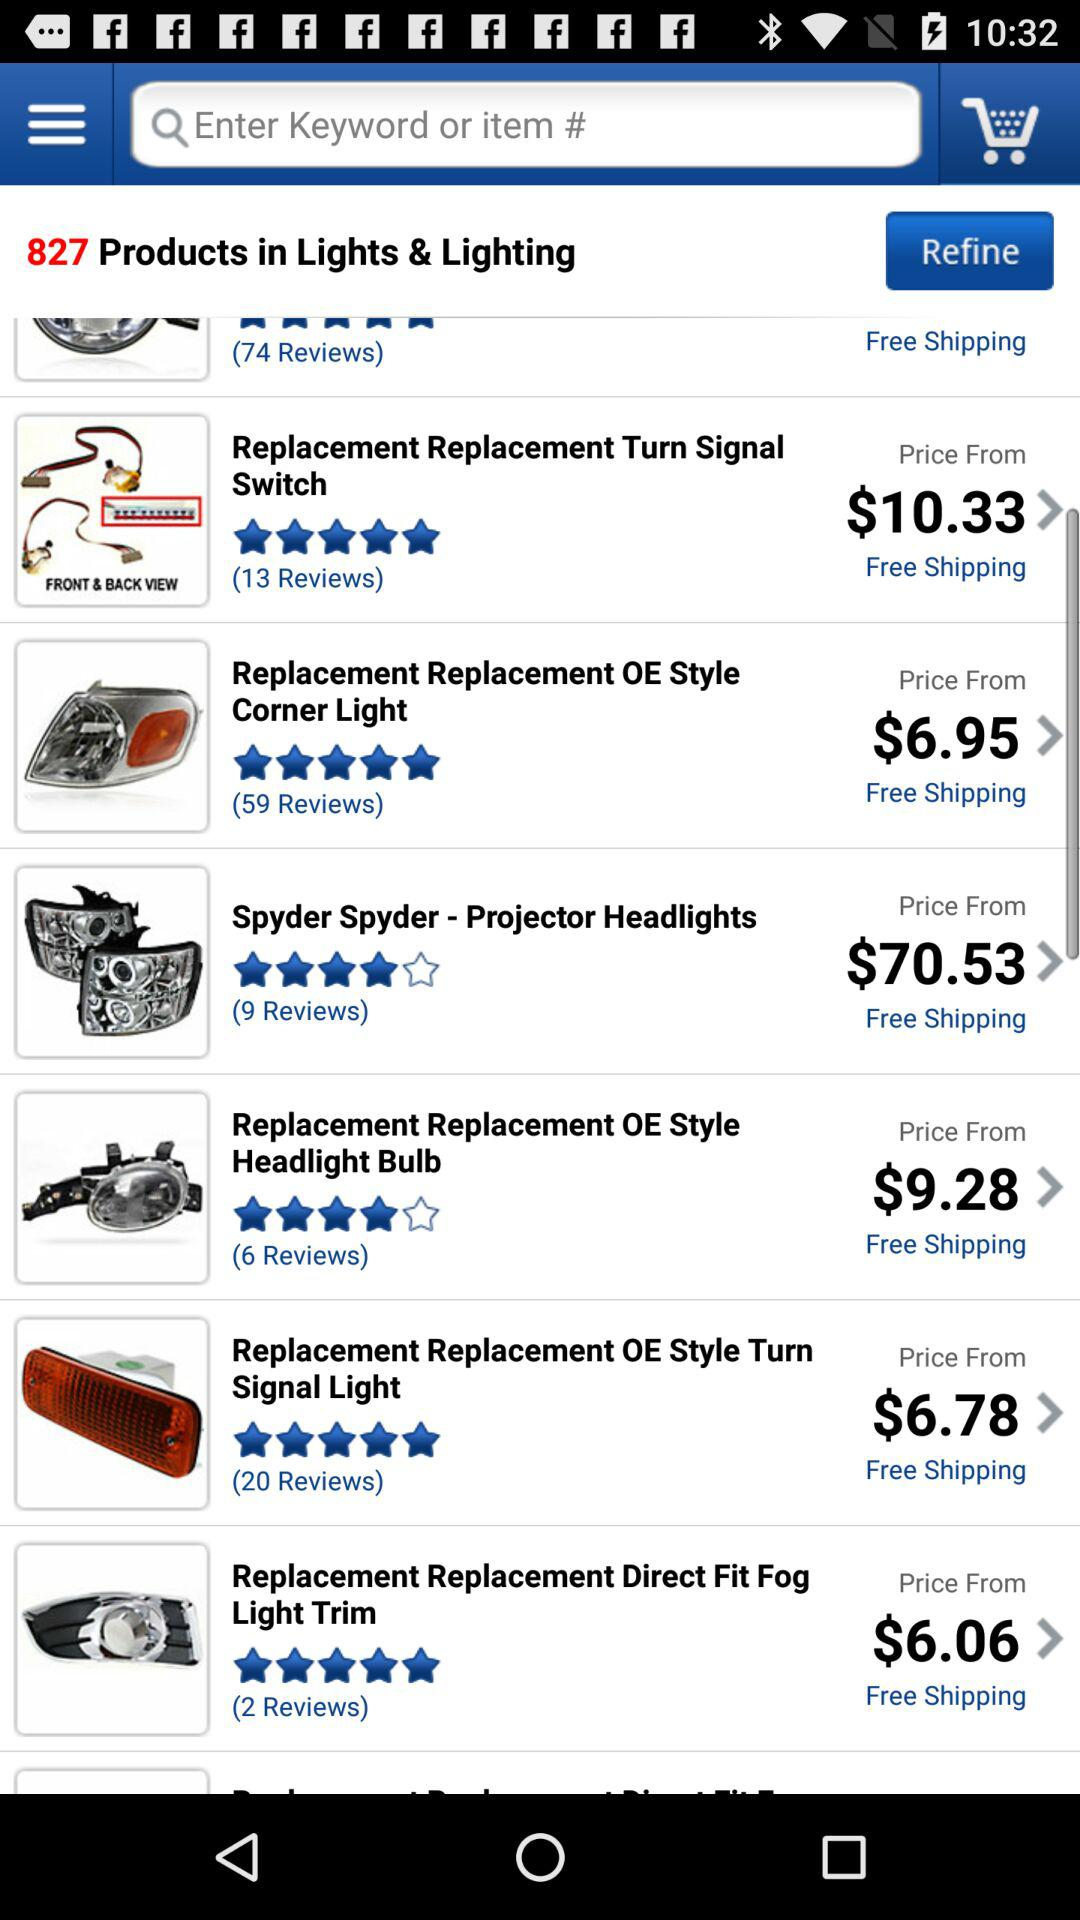By how many people was "Spyder Spyder" reviewed? "Spyder Spyder" was reviewed by 9 people. 